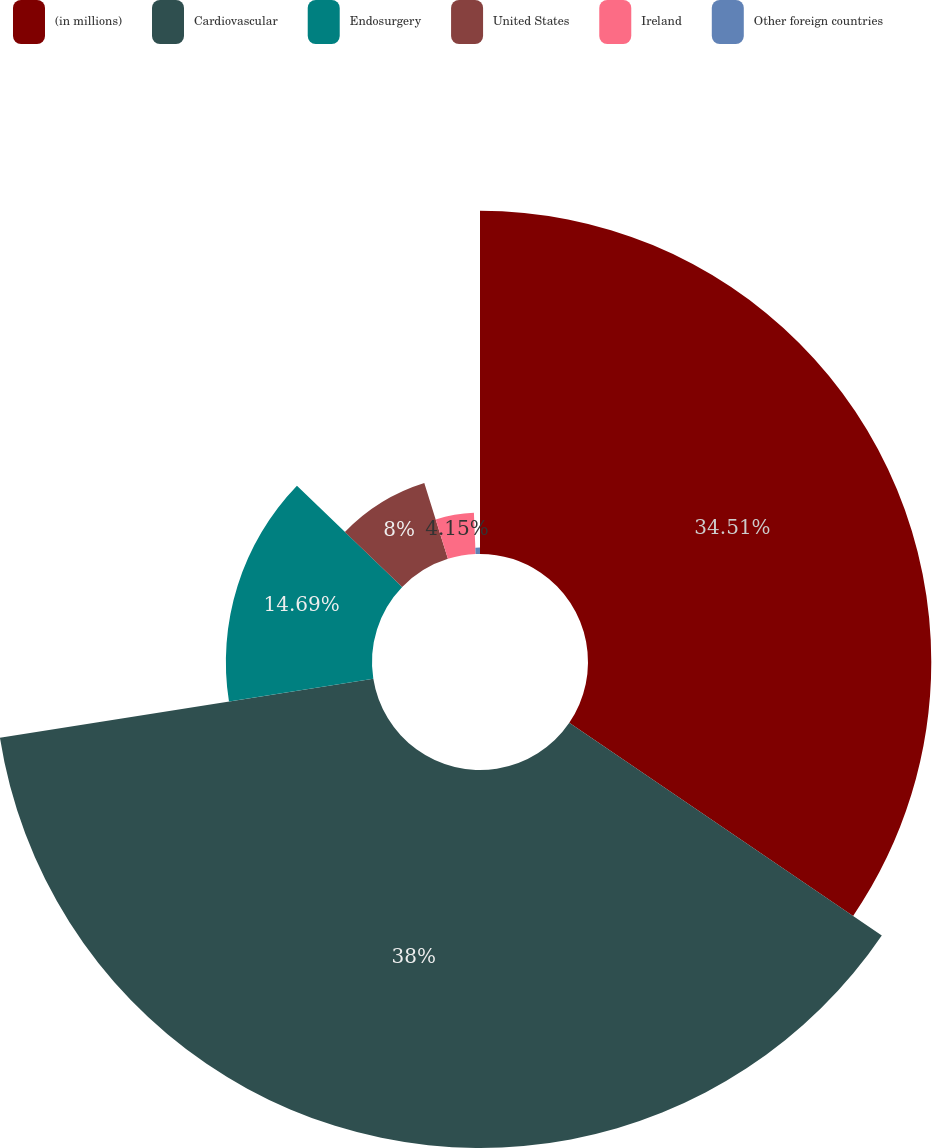<chart> <loc_0><loc_0><loc_500><loc_500><pie_chart><fcel>(in millions)<fcel>Cardiovascular<fcel>Endosurgery<fcel>United States<fcel>Ireland<fcel>Other foreign countries<nl><fcel>34.51%<fcel>38.0%<fcel>14.69%<fcel>8.0%<fcel>4.15%<fcel>0.65%<nl></chart> 